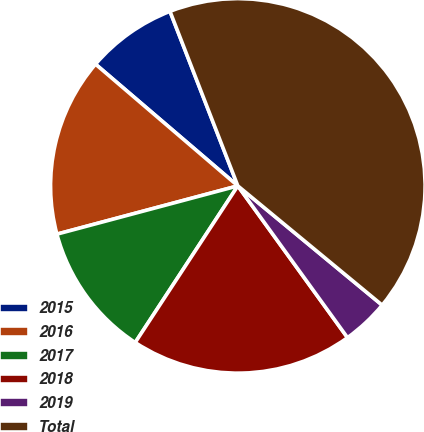Convert chart to OTSL. <chart><loc_0><loc_0><loc_500><loc_500><pie_chart><fcel>2015<fcel>2016<fcel>2017<fcel>2018<fcel>2019<fcel>Total<nl><fcel>7.84%<fcel>15.41%<fcel>11.62%<fcel>19.19%<fcel>4.05%<fcel>41.89%<nl></chart> 